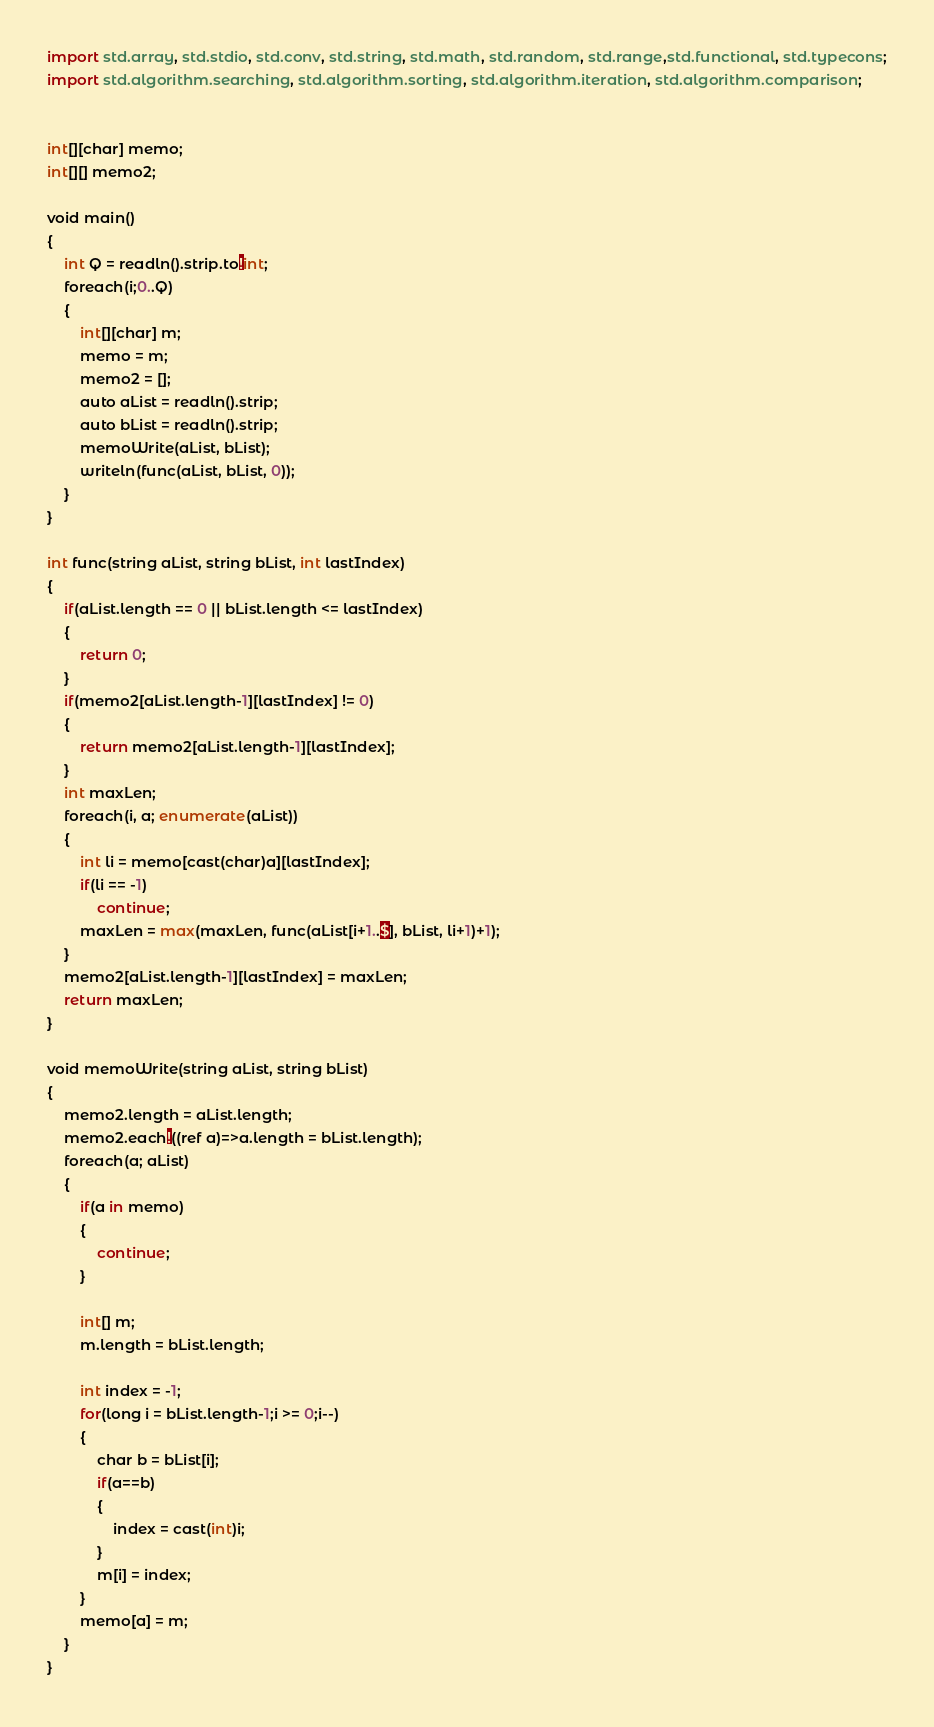Convert code to text. <code><loc_0><loc_0><loc_500><loc_500><_Python_>import std.array, std.stdio, std.conv, std.string, std.math, std.random, std.range,std.functional, std.typecons;
import std.algorithm.searching, std.algorithm.sorting, std.algorithm.iteration, std.algorithm.comparison;

 
int[][char] memo;
int[][] memo2;
 
void main()
{
    int Q = readln().strip.to!int;
    foreach(i;0..Q)
    {
        int[][char] m;
        memo = m;
        memo2 = [];
        auto aList = readln().strip;
        auto bList = readln().strip;
        memoWrite(aList, bList);
        writeln(func(aList, bList, 0));
    }
}

int func(string aList, string bList, int lastIndex)
{
    if(aList.length == 0 || bList.length <= lastIndex)
    {
        return 0;
    }
    if(memo2[aList.length-1][lastIndex] != 0)
    {
        return memo2[aList.length-1][lastIndex];
    }
    int maxLen;
    foreach(i, a; enumerate(aList))
    {
        int li = memo[cast(char)a][lastIndex];
        if(li == -1)
            continue;
        maxLen = max(maxLen, func(aList[i+1..$], bList, li+1)+1);
    }
    memo2[aList.length-1][lastIndex] = maxLen;
    return maxLen;
}

void memoWrite(string aList, string bList)
{
    memo2.length = aList.length;
    memo2.each!((ref a)=>a.length = bList.length);
    foreach(a; aList)
    {
        if(a in memo)
        {
            continue;
        }

        int[] m;
        m.length = bList.length;

        int index = -1;
        for(long i = bList.length-1;i >= 0;i--)
        {
            char b = bList[i];
            if(a==b)
            {
                index = cast(int)i;
            }
            m[i] = index;
        }
        memo[a] = m;
    }
}
</code> 